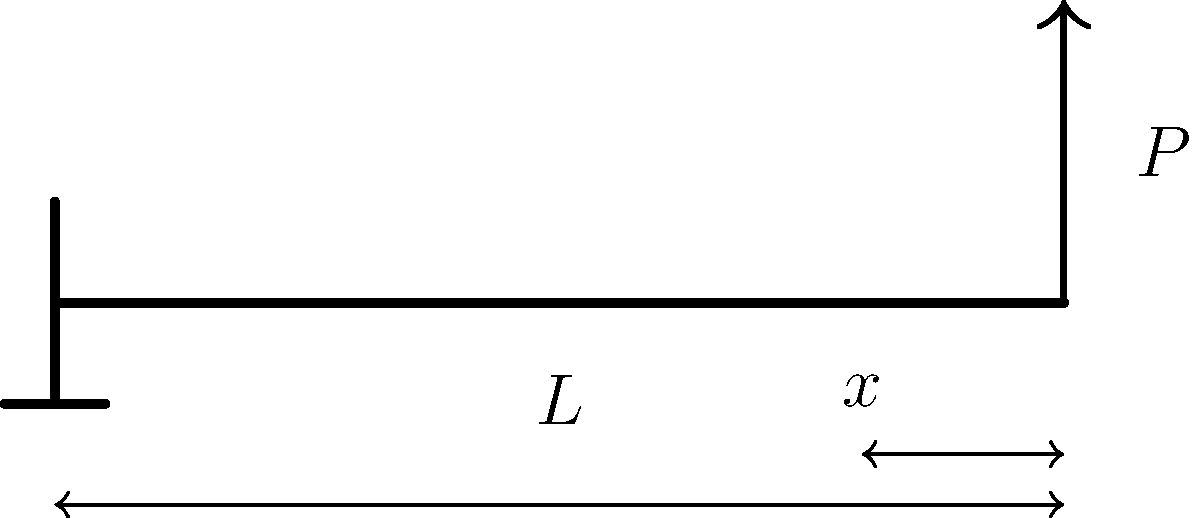A cantilever beam of length $L$ is subjected to a point load $P$ at its free end, as shown in the figure. If the beam has a rectangular cross-section with width $b$ and height $h$, determine the maximum bending stress $\sigma_{max}$ at a distance $x$ from the fixed end. Express your answer in terms of $P$, $L$, $b$, $h$, and $x$. Let's approach this step-by-step:

1) The bending moment $M$ at any point $x$ along the beam is given by:
   $$M = P(L-x)$$

2) The moment of inertia $I$ for a rectangular cross-section is:
   $$I = \frac{bh^3}{12}$$

3) The bending stress $\sigma$ at any point in the beam is given by the flexure formula:
   $$\sigma = \frac{My}{I}$$
   where $y$ is the distance from the neutral axis.

4) The maximum stress occurs at the outer fibers of the beam, where $y = h/2$. So:
   $$\sigma_{max} = \frac{M(h/2)}{I}$$

5) Substituting the expressions for $M$ and $I$:
   $$\sigma_{max} = \frac{P(L-x)(h/2)}{\frac{bh^3}{12}}$$

6) Simplifying:
   $$\sigma_{max} = \frac{6P(L-x)}{bh^2}$$

This equation gives the maximum bending stress at any point $x$ along the beam.
Answer: $\sigma_{max} = \frac{6P(L-x)}{bh^2}$ 